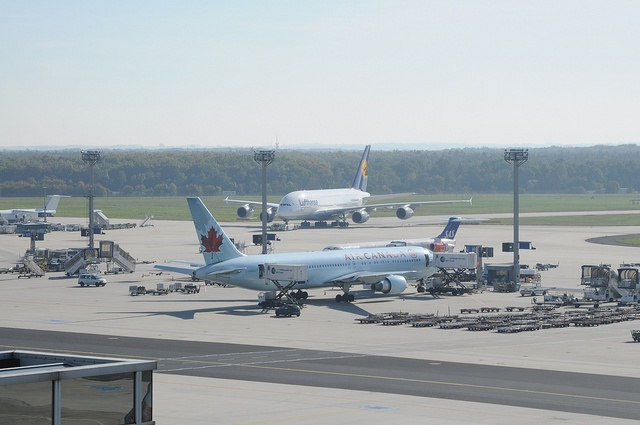Describe the objects in this image and their specific colors. I can see airplane in lightblue, gray, and darkgray tones, airplane in lightblue, darkgray, lightgray, and gray tones, airplane in lightblue, darkgray, gray, and lightgray tones, car in lightblue, gray, black, and blue tones, and car in lightblue, darkgray, and gray tones in this image. 